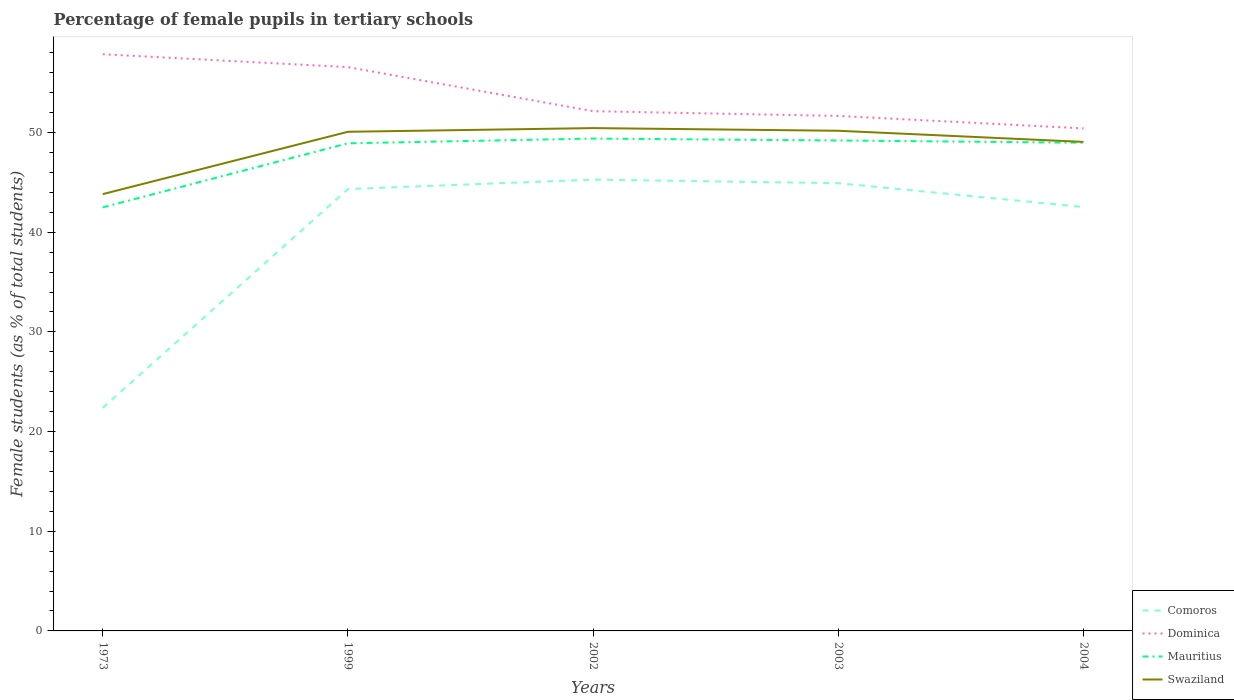How many different coloured lines are there?
Your answer should be very brief. 4. Across all years, what is the maximum percentage of female pupils in tertiary schools in Mauritius?
Your answer should be compact. 42.5. What is the total percentage of female pupils in tertiary schools in Mauritius in the graph?
Your response must be concise. 0.42. What is the difference between the highest and the second highest percentage of female pupils in tertiary schools in Swaziland?
Provide a succinct answer. 6.63. What is the difference between the highest and the lowest percentage of female pupils in tertiary schools in Mauritius?
Make the answer very short. 4. How many lines are there?
Make the answer very short. 4. What is the difference between two consecutive major ticks on the Y-axis?
Offer a terse response. 10. Does the graph contain any zero values?
Give a very brief answer. No. Does the graph contain grids?
Your answer should be very brief. No. Where does the legend appear in the graph?
Offer a very short reply. Bottom right. What is the title of the graph?
Offer a very short reply. Percentage of female pupils in tertiary schools. What is the label or title of the X-axis?
Offer a terse response. Years. What is the label or title of the Y-axis?
Give a very brief answer. Female students (as % of total students). What is the Female students (as % of total students) in Comoros in 1973?
Keep it short and to the point. 22.38. What is the Female students (as % of total students) in Dominica in 1973?
Offer a very short reply. 57.86. What is the Female students (as % of total students) of Mauritius in 1973?
Provide a succinct answer. 42.5. What is the Female students (as % of total students) in Swaziland in 1973?
Give a very brief answer. 43.82. What is the Female students (as % of total students) of Comoros in 1999?
Give a very brief answer. 44.33. What is the Female students (as % of total students) in Dominica in 1999?
Offer a very short reply. 56.57. What is the Female students (as % of total students) of Mauritius in 1999?
Offer a very short reply. 48.92. What is the Female students (as % of total students) in Swaziland in 1999?
Make the answer very short. 50.08. What is the Female students (as % of total students) in Comoros in 2002?
Your response must be concise. 45.28. What is the Female students (as % of total students) of Dominica in 2002?
Offer a very short reply. 52.15. What is the Female students (as % of total students) in Mauritius in 2002?
Provide a short and direct response. 49.4. What is the Female students (as % of total students) in Swaziland in 2002?
Make the answer very short. 50.45. What is the Female students (as % of total students) of Comoros in 2003?
Make the answer very short. 44.92. What is the Female students (as % of total students) of Dominica in 2003?
Keep it short and to the point. 51.67. What is the Female students (as % of total students) of Mauritius in 2003?
Provide a succinct answer. 49.21. What is the Female students (as % of total students) in Swaziland in 2003?
Ensure brevity in your answer.  50.18. What is the Female students (as % of total students) in Comoros in 2004?
Ensure brevity in your answer.  42.53. What is the Female students (as % of total students) of Dominica in 2004?
Your answer should be very brief. 50.42. What is the Female students (as % of total students) of Mauritius in 2004?
Offer a very short reply. 48.98. What is the Female students (as % of total students) of Swaziland in 2004?
Offer a terse response. 49.06. Across all years, what is the maximum Female students (as % of total students) in Comoros?
Make the answer very short. 45.28. Across all years, what is the maximum Female students (as % of total students) of Dominica?
Ensure brevity in your answer.  57.86. Across all years, what is the maximum Female students (as % of total students) in Mauritius?
Ensure brevity in your answer.  49.4. Across all years, what is the maximum Female students (as % of total students) in Swaziland?
Offer a terse response. 50.45. Across all years, what is the minimum Female students (as % of total students) in Comoros?
Offer a terse response. 22.38. Across all years, what is the minimum Female students (as % of total students) of Dominica?
Ensure brevity in your answer.  50.42. Across all years, what is the minimum Female students (as % of total students) in Mauritius?
Provide a succinct answer. 42.5. Across all years, what is the minimum Female students (as % of total students) in Swaziland?
Offer a very short reply. 43.82. What is the total Female students (as % of total students) in Comoros in the graph?
Give a very brief answer. 199.44. What is the total Female students (as % of total students) in Dominica in the graph?
Keep it short and to the point. 268.66. What is the total Female students (as % of total students) of Mauritius in the graph?
Ensure brevity in your answer.  239.01. What is the total Female students (as % of total students) of Swaziland in the graph?
Provide a succinct answer. 243.6. What is the difference between the Female students (as % of total students) in Comoros in 1973 and that in 1999?
Your response must be concise. -21.95. What is the difference between the Female students (as % of total students) of Dominica in 1973 and that in 1999?
Your answer should be compact. 1.29. What is the difference between the Female students (as % of total students) of Mauritius in 1973 and that in 1999?
Your response must be concise. -6.42. What is the difference between the Female students (as % of total students) in Swaziland in 1973 and that in 1999?
Your answer should be very brief. -6.26. What is the difference between the Female students (as % of total students) in Comoros in 1973 and that in 2002?
Your answer should be compact. -22.9. What is the difference between the Female students (as % of total students) of Dominica in 1973 and that in 2002?
Ensure brevity in your answer.  5.71. What is the difference between the Female students (as % of total students) of Mauritius in 1973 and that in 2002?
Offer a very short reply. -6.9. What is the difference between the Female students (as % of total students) in Swaziland in 1973 and that in 2002?
Make the answer very short. -6.63. What is the difference between the Female students (as % of total students) of Comoros in 1973 and that in 2003?
Provide a short and direct response. -22.54. What is the difference between the Female students (as % of total students) of Dominica in 1973 and that in 2003?
Provide a short and direct response. 6.19. What is the difference between the Female students (as % of total students) of Mauritius in 1973 and that in 2003?
Offer a very short reply. -6.71. What is the difference between the Female students (as % of total students) of Swaziland in 1973 and that in 2003?
Give a very brief answer. -6.36. What is the difference between the Female students (as % of total students) in Comoros in 1973 and that in 2004?
Offer a terse response. -20.15. What is the difference between the Female students (as % of total students) in Dominica in 1973 and that in 2004?
Your answer should be very brief. 7.44. What is the difference between the Female students (as % of total students) of Mauritius in 1973 and that in 2004?
Keep it short and to the point. -6.48. What is the difference between the Female students (as % of total students) in Swaziland in 1973 and that in 2004?
Give a very brief answer. -5.24. What is the difference between the Female students (as % of total students) of Comoros in 1999 and that in 2002?
Keep it short and to the point. -0.95. What is the difference between the Female students (as % of total students) in Dominica in 1999 and that in 2002?
Offer a terse response. 4.42. What is the difference between the Female students (as % of total students) of Mauritius in 1999 and that in 2002?
Your response must be concise. -0.48. What is the difference between the Female students (as % of total students) in Swaziland in 1999 and that in 2002?
Make the answer very short. -0.37. What is the difference between the Female students (as % of total students) of Comoros in 1999 and that in 2003?
Provide a short and direct response. -0.59. What is the difference between the Female students (as % of total students) in Dominica in 1999 and that in 2003?
Offer a very short reply. 4.9. What is the difference between the Female students (as % of total students) in Mauritius in 1999 and that in 2003?
Ensure brevity in your answer.  -0.28. What is the difference between the Female students (as % of total students) of Swaziland in 1999 and that in 2003?
Ensure brevity in your answer.  -0.1. What is the difference between the Female students (as % of total students) of Comoros in 1999 and that in 2004?
Ensure brevity in your answer.  1.8. What is the difference between the Female students (as % of total students) in Dominica in 1999 and that in 2004?
Your response must be concise. 6.15. What is the difference between the Female students (as % of total students) in Mauritius in 1999 and that in 2004?
Give a very brief answer. -0.06. What is the difference between the Female students (as % of total students) of Swaziland in 1999 and that in 2004?
Provide a succinct answer. 1.02. What is the difference between the Female students (as % of total students) in Comoros in 2002 and that in 2003?
Give a very brief answer. 0.36. What is the difference between the Female students (as % of total students) in Dominica in 2002 and that in 2003?
Keep it short and to the point. 0.48. What is the difference between the Female students (as % of total students) in Mauritius in 2002 and that in 2003?
Keep it short and to the point. 0.19. What is the difference between the Female students (as % of total students) in Swaziland in 2002 and that in 2003?
Provide a succinct answer. 0.27. What is the difference between the Female students (as % of total students) of Comoros in 2002 and that in 2004?
Give a very brief answer. 2.75. What is the difference between the Female students (as % of total students) in Dominica in 2002 and that in 2004?
Ensure brevity in your answer.  1.73. What is the difference between the Female students (as % of total students) of Mauritius in 2002 and that in 2004?
Ensure brevity in your answer.  0.42. What is the difference between the Female students (as % of total students) of Swaziland in 2002 and that in 2004?
Your answer should be compact. 1.39. What is the difference between the Female students (as % of total students) of Comoros in 2003 and that in 2004?
Your response must be concise. 2.39. What is the difference between the Female students (as % of total students) of Dominica in 2003 and that in 2004?
Your answer should be very brief. 1.25. What is the difference between the Female students (as % of total students) in Mauritius in 2003 and that in 2004?
Provide a succinct answer. 0.23. What is the difference between the Female students (as % of total students) in Swaziland in 2003 and that in 2004?
Keep it short and to the point. 1.12. What is the difference between the Female students (as % of total students) of Comoros in 1973 and the Female students (as % of total students) of Dominica in 1999?
Your answer should be very brief. -34.19. What is the difference between the Female students (as % of total students) in Comoros in 1973 and the Female students (as % of total students) in Mauritius in 1999?
Offer a terse response. -26.54. What is the difference between the Female students (as % of total students) in Comoros in 1973 and the Female students (as % of total students) in Swaziland in 1999?
Make the answer very short. -27.7. What is the difference between the Female students (as % of total students) of Dominica in 1973 and the Female students (as % of total students) of Mauritius in 1999?
Offer a terse response. 8.93. What is the difference between the Female students (as % of total students) of Dominica in 1973 and the Female students (as % of total students) of Swaziland in 1999?
Offer a very short reply. 7.78. What is the difference between the Female students (as % of total students) of Mauritius in 1973 and the Female students (as % of total students) of Swaziland in 1999?
Provide a short and direct response. -7.58. What is the difference between the Female students (as % of total students) in Comoros in 1973 and the Female students (as % of total students) in Dominica in 2002?
Provide a succinct answer. -29.77. What is the difference between the Female students (as % of total students) in Comoros in 1973 and the Female students (as % of total students) in Mauritius in 2002?
Make the answer very short. -27.02. What is the difference between the Female students (as % of total students) of Comoros in 1973 and the Female students (as % of total students) of Swaziland in 2002?
Make the answer very short. -28.07. What is the difference between the Female students (as % of total students) of Dominica in 1973 and the Female students (as % of total students) of Mauritius in 2002?
Provide a succinct answer. 8.46. What is the difference between the Female students (as % of total students) in Dominica in 1973 and the Female students (as % of total students) in Swaziland in 2002?
Your answer should be compact. 7.41. What is the difference between the Female students (as % of total students) of Mauritius in 1973 and the Female students (as % of total students) of Swaziland in 2002?
Make the answer very short. -7.95. What is the difference between the Female students (as % of total students) in Comoros in 1973 and the Female students (as % of total students) in Dominica in 2003?
Your answer should be very brief. -29.29. What is the difference between the Female students (as % of total students) of Comoros in 1973 and the Female students (as % of total students) of Mauritius in 2003?
Offer a very short reply. -26.83. What is the difference between the Female students (as % of total students) in Comoros in 1973 and the Female students (as % of total students) in Swaziland in 2003?
Make the answer very short. -27.8. What is the difference between the Female students (as % of total students) of Dominica in 1973 and the Female students (as % of total students) of Mauritius in 2003?
Keep it short and to the point. 8.65. What is the difference between the Female students (as % of total students) in Dominica in 1973 and the Female students (as % of total students) in Swaziland in 2003?
Your response must be concise. 7.68. What is the difference between the Female students (as % of total students) of Mauritius in 1973 and the Female students (as % of total students) of Swaziland in 2003?
Ensure brevity in your answer.  -7.68. What is the difference between the Female students (as % of total students) of Comoros in 1973 and the Female students (as % of total students) of Dominica in 2004?
Your answer should be very brief. -28.04. What is the difference between the Female students (as % of total students) of Comoros in 1973 and the Female students (as % of total students) of Mauritius in 2004?
Give a very brief answer. -26.6. What is the difference between the Female students (as % of total students) of Comoros in 1973 and the Female students (as % of total students) of Swaziland in 2004?
Give a very brief answer. -26.69. What is the difference between the Female students (as % of total students) in Dominica in 1973 and the Female students (as % of total students) in Mauritius in 2004?
Offer a terse response. 8.88. What is the difference between the Female students (as % of total students) of Dominica in 1973 and the Female students (as % of total students) of Swaziland in 2004?
Provide a short and direct response. 8.79. What is the difference between the Female students (as % of total students) in Mauritius in 1973 and the Female students (as % of total students) in Swaziland in 2004?
Offer a terse response. -6.57. What is the difference between the Female students (as % of total students) in Comoros in 1999 and the Female students (as % of total students) in Dominica in 2002?
Keep it short and to the point. -7.82. What is the difference between the Female students (as % of total students) of Comoros in 1999 and the Female students (as % of total students) of Mauritius in 2002?
Offer a terse response. -5.07. What is the difference between the Female students (as % of total students) in Comoros in 1999 and the Female students (as % of total students) in Swaziland in 2002?
Your answer should be compact. -6.12. What is the difference between the Female students (as % of total students) in Dominica in 1999 and the Female students (as % of total students) in Mauritius in 2002?
Ensure brevity in your answer.  7.17. What is the difference between the Female students (as % of total students) in Dominica in 1999 and the Female students (as % of total students) in Swaziland in 2002?
Your answer should be compact. 6.12. What is the difference between the Female students (as % of total students) of Mauritius in 1999 and the Female students (as % of total students) of Swaziland in 2002?
Provide a succinct answer. -1.53. What is the difference between the Female students (as % of total students) in Comoros in 1999 and the Female students (as % of total students) in Dominica in 2003?
Offer a very short reply. -7.34. What is the difference between the Female students (as % of total students) of Comoros in 1999 and the Female students (as % of total students) of Mauritius in 2003?
Offer a terse response. -4.88. What is the difference between the Female students (as % of total students) in Comoros in 1999 and the Female students (as % of total students) in Swaziland in 2003?
Offer a terse response. -5.85. What is the difference between the Female students (as % of total students) in Dominica in 1999 and the Female students (as % of total students) in Mauritius in 2003?
Offer a very short reply. 7.36. What is the difference between the Female students (as % of total students) in Dominica in 1999 and the Female students (as % of total students) in Swaziland in 2003?
Offer a terse response. 6.39. What is the difference between the Female students (as % of total students) of Mauritius in 1999 and the Female students (as % of total students) of Swaziland in 2003?
Your answer should be compact. -1.26. What is the difference between the Female students (as % of total students) in Comoros in 1999 and the Female students (as % of total students) in Dominica in 2004?
Your answer should be very brief. -6.09. What is the difference between the Female students (as % of total students) of Comoros in 1999 and the Female students (as % of total students) of Mauritius in 2004?
Ensure brevity in your answer.  -4.65. What is the difference between the Female students (as % of total students) in Comoros in 1999 and the Female students (as % of total students) in Swaziland in 2004?
Offer a terse response. -4.73. What is the difference between the Female students (as % of total students) of Dominica in 1999 and the Female students (as % of total students) of Mauritius in 2004?
Ensure brevity in your answer.  7.59. What is the difference between the Female students (as % of total students) of Dominica in 1999 and the Female students (as % of total students) of Swaziland in 2004?
Your response must be concise. 7.5. What is the difference between the Female students (as % of total students) of Mauritius in 1999 and the Female students (as % of total students) of Swaziland in 2004?
Your answer should be very brief. -0.14. What is the difference between the Female students (as % of total students) of Comoros in 2002 and the Female students (as % of total students) of Dominica in 2003?
Provide a short and direct response. -6.39. What is the difference between the Female students (as % of total students) of Comoros in 2002 and the Female students (as % of total students) of Mauritius in 2003?
Provide a short and direct response. -3.93. What is the difference between the Female students (as % of total students) of Comoros in 2002 and the Female students (as % of total students) of Swaziland in 2003?
Keep it short and to the point. -4.9. What is the difference between the Female students (as % of total students) of Dominica in 2002 and the Female students (as % of total students) of Mauritius in 2003?
Your answer should be very brief. 2.94. What is the difference between the Female students (as % of total students) of Dominica in 2002 and the Female students (as % of total students) of Swaziland in 2003?
Provide a short and direct response. 1.97. What is the difference between the Female students (as % of total students) of Mauritius in 2002 and the Female students (as % of total students) of Swaziland in 2003?
Give a very brief answer. -0.78. What is the difference between the Female students (as % of total students) in Comoros in 2002 and the Female students (as % of total students) in Dominica in 2004?
Your response must be concise. -5.14. What is the difference between the Female students (as % of total students) in Comoros in 2002 and the Female students (as % of total students) in Mauritius in 2004?
Your response must be concise. -3.7. What is the difference between the Female students (as % of total students) of Comoros in 2002 and the Female students (as % of total students) of Swaziland in 2004?
Your answer should be compact. -3.79. What is the difference between the Female students (as % of total students) of Dominica in 2002 and the Female students (as % of total students) of Mauritius in 2004?
Your answer should be compact. 3.17. What is the difference between the Female students (as % of total students) of Dominica in 2002 and the Female students (as % of total students) of Swaziland in 2004?
Provide a succinct answer. 3.08. What is the difference between the Female students (as % of total students) of Mauritius in 2002 and the Female students (as % of total students) of Swaziland in 2004?
Give a very brief answer. 0.34. What is the difference between the Female students (as % of total students) of Comoros in 2003 and the Female students (as % of total students) of Dominica in 2004?
Make the answer very short. -5.5. What is the difference between the Female students (as % of total students) of Comoros in 2003 and the Female students (as % of total students) of Mauritius in 2004?
Provide a succinct answer. -4.06. What is the difference between the Female students (as % of total students) of Comoros in 2003 and the Female students (as % of total students) of Swaziland in 2004?
Offer a terse response. -4.14. What is the difference between the Female students (as % of total students) in Dominica in 2003 and the Female students (as % of total students) in Mauritius in 2004?
Ensure brevity in your answer.  2.69. What is the difference between the Female students (as % of total students) of Dominica in 2003 and the Female students (as % of total students) of Swaziland in 2004?
Your response must be concise. 2.61. What is the difference between the Female students (as % of total students) of Mauritius in 2003 and the Female students (as % of total students) of Swaziland in 2004?
Your response must be concise. 0.14. What is the average Female students (as % of total students) of Comoros per year?
Your answer should be compact. 39.89. What is the average Female students (as % of total students) in Dominica per year?
Your answer should be very brief. 53.73. What is the average Female students (as % of total students) in Mauritius per year?
Keep it short and to the point. 47.8. What is the average Female students (as % of total students) of Swaziland per year?
Provide a succinct answer. 48.72. In the year 1973, what is the difference between the Female students (as % of total students) in Comoros and Female students (as % of total students) in Dominica?
Provide a succinct answer. -35.48. In the year 1973, what is the difference between the Female students (as % of total students) of Comoros and Female students (as % of total students) of Mauritius?
Offer a very short reply. -20.12. In the year 1973, what is the difference between the Female students (as % of total students) of Comoros and Female students (as % of total students) of Swaziland?
Provide a short and direct response. -21.45. In the year 1973, what is the difference between the Female students (as % of total students) in Dominica and Female students (as % of total students) in Mauritius?
Your response must be concise. 15.36. In the year 1973, what is the difference between the Female students (as % of total students) of Dominica and Female students (as % of total students) of Swaziland?
Ensure brevity in your answer.  14.03. In the year 1973, what is the difference between the Female students (as % of total students) in Mauritius and Female students (as % of total students) in Swaziland?
Your answer should be compact. -1.33. In the year 1999, what is the difference between the Female students (as % of total students) in Comoros and Female students (as % of total students) in Dominica?
Provide a succinct answer. -12.24. In the year 1999, what is the difference between the Female students (as % of total students) of Comoros and Female students (as % of total students) of Mauritius?
Your response must be concise. -4.59. In the year 1999, what is the difference between the Female students (as % of total students) in Comoros and Female students (as % of total students) in Swaziland?
Ensure brevity in your answer.  -5.75. In the year 1999, what is the difference between the Female students (as % of total students) of Dominica and Female students (as % of total students) of Mauritius?
Your response must be concise. 7.64. In the year 1999, what is the difference between the Female students (as % of total students) in Dominica and Female students (as % of total students) in Swaziland?
Provide a short and direct response. 6.49. In the year 1999, what is the difference between the Female students (as % of total students) of Mauritius and Female students (as % of total students) of Swaziland?
Offer a very short reply. -1.16. In the year 2002, what is the difference between the Female students (as % of total students) in Comoros and Female students (as % of total students) in Dominica?
Your response must be concise. -6.87. In the year 2002, what is the difference between the Female students (as % of total students) in Comoros and Female students (as % of total students) in Mauritius?
Your answer should be compact. -4.12. In the year 2002, what is the difference between the Female students (as % of total students) of Comoros and Female students (as % of total students) of Swaziland?
Give a very brief answer. -5.17. In the year 2002, what is the difference between the Female students (as % of total students) in Dominica and Female students (as % of total students) in Mauritius?
Offer a very short reply. 2.75. In the year 2002, what is the difference between the Female students (as % of total students) in Dominica and Female students (as % of total students) in Swaziland?
Provide a succinct answer. 1.7. In the year 2002, what is the difference between the Female students (as % of total students) of Mauritius and Female students (as % of total students) of Swaziland?
Offer a very short reply. -1.05. In the year 2003, what is the difference between the Female students (as % of total students) in Comoros and Female students (as % of total students) in Dominica?
Offer a very short reply. -6.75. In the year 2003, what is the difference between the Female students (as % of total students) of Comoros and Female students (as % of total students) of Mauritius?
Ensure brevity in your answer.  -4.28. In the year 2003, what is the difference between the Female students (as % of total students) of Comoros and Female students (as % of total students) of Swaziland?
Your answer should be compact. -5.26. In the year 2003, what is the difference between the Female students (as % of total students) of Dominica and Female students (as % of total students) of Mauritius?
Your answer should be compact. 2.46. In the year 2003, what is the difference between the Female students (as % of total students) in Dominica and Female students (as % of total students) in Swaziland?
Give a very brief answer. 1.49. In the year 2003, what is the difference between the Female students (as % of total students) of Mauritius and Female students (as % of total students) of Swaziland?
Keep it short and to the point. -0.97. In the year 2004, what is the difference between the Female students (as % of total students) of Comoros and Female students (as % of total students) of Dominica?
Make the answer very short. -7.89. In the year 2004, what is the difference between the Female students (as % of total students) in Comoros and Female students (as % of total students) in Mauritius?
Offer a terse response. -6.45. In the year 2004, what is the difference between the Female students (as % of total students) of Comoros and Female students (as % of total students) of Swaziland?
Make the answer very short. -6.53. In the year 2004, what is the difference between the Female students (as % of total students) of Dominica and Female students (as % of total students) of Mauritius?
Give a very brief answer. 1.44. In the year 2004, what is the difference between the Female students (as % of total students) of Dominica and Female students (as % of total students) of Swaziland?
Give a very brief answer. 1.36. In the year 2004, what is the difference between the Female students (as % of total students) of Mauritius and Female students (as % of total students) of Swaziland?
Make the answer very short. -0.08. What is the ratio of the Female students (as % of total students) of Comoros in 1973 to that in 1999?
Provide a succinct answer. 0.5. What is the ratio of the Female students (as % of total students) in Dominica in 1973 to that in 1999?
Provide a short and direct response. 1.02. What is the ratio of the Female students (as % of total students) in Mauritius in 1973 to that in 1999?
Offer a very short reply. 0.87. What is the ratio of the Female students (as % of total students) in Swaziland in 1973 to that in 1999?
Offer a very short reply. 0.88. What is the ratio of the Female students (as % of total students) of Comoros in 1973 to that in 2002?
Make the answer very short. 0.49. What is the ratio of the Female students (as % of total students) in Dominica in 1973 to that in 2002?
Provide a short and direct response. 1.11. What is the ratio of the Female students (as % of total students) of Mauritius in 1973 to that in 2002?
Make the answer very short. 0.86. What is the ratio of the Female students (as % of total students) in Swaziland in 1973 to that in 2002?
Provide a short and direct response. 0.87. What is the ratio of the Female students (as % of total students) of Comoros in 1973 to that in 2003?
Offer a very short reply. 0.5. What is the ratio of the Female students (as % of total students) of Dominica in 1973 to that in 2003?
Your answer should be compact. 1.12. What is the ratio of the Female students (as % of total students) of Mauritius in 1973 to that in 2003?
Your answer should be very brief. 0.86. What is the ratio of the Female students (as % of total students) of Swaziland in 1973 to that in 2003?
Offer a terse response. 0.87. What is the ratio of the Female students (as % of total students) in Comoros in 1973 to that in 2004?
Provide a short and direct response. 0.53. What is the ratio of the Female students (as % of total students) of Dominica in 1973 to that in 2004?
Your response must be concise. 1.15. What is the ratio of the Female students (as % of total students) in Mauritius in 1973 to that in 2004?
Ensure brevity in your answer.  0.87. What is the ratio of the Female students (as % of total students) in Swaziland in 1973 to that in 2004?
Provide a short and direct response. 0.89. What is the ratio of the Female students (as % of total students) of Comoros in 1999 to that in 2002?
Make the answer very short. 0.98. What is the ratio of the Female students (as % of total students) in Dominica in 1999 to that in 2002?
Your answer should be compact. 1.08. What is the ratio of the Female students (as % of total students) of Mauritius in 1999 to that in 2002?
Keep it short and to the point. 0.99. What is the ratio of the Female students (as % of total students) in Dominica in 1999 to that in 2003?
Offer a terse response. 1.09. What is the ratio of the Female students (as % of total students) of Mauritius in 1999 to that in 2003?
Provide a succinct answer. 0.99. What is the ratio of the Female students (as % of total students) in Swaziland in 1999 to that in 2003?
Offer a terse response. 1. What is the ratio of the Female students (as % of total students) of Comoros in 1999 to that in 2004?
Keep it short and to the point. 1.04. What is the ratio of the Female students (as % of total students) in Dominica in 1999 to that in 2004?
Make the answer very short. 1.12. What is the ratio of the Female students (as % of total students) in Swaziland in 1999 to that in 2004?
Make the answer very short. 1.02. What is the ratio of the Female students (as % of total students) in Comoros in 2002 to that in 2003?
Make the answer very short. 1.01. What is the ratio of the Female students (as % of total students) of Dominica in 2002 to that in 2003?
Provide a succinct answer. 1.01. What is the ratio of the Female students (as % of total students) of Mauritius in 2002 to that in 2003?
Keep it short and to the point. 1. What is the ratio of the Female students (as % of total students) in Swaziland in 2002 to that in 2003?
Offer a very short reply. 1.01. What is the ratio of the Female students (as % of total students) of Comoros in 2002 to that in 2004?
Your answer should be compact. 1.06. What is the ratio of the Female students (as % of total students) in Dominica in 2002 to that in 2004?
Your answer should be very brief. 1.03. What is the ratio of the Female students (as % of total students) of Mauritius in 2002 to that in 2004?
Your answer should be very brief. 1.01. What is the ratio of the Female students (as % of total students) in Swaziland in 2002 to that in 2004?
Your answer should be compact. 1.03. What is the ratio of the Female students (as % of total students) in Comoros in 2003 to that in 2004?
Your response must be concise. 1.06. What is the ratio of the Female students (as % of total students) of Dominica in 2003 to that in 2004?
Provide a succinct answer. 1.02. What is the ratio of the Female students (as % of total students) of Swaziland in 2003 to that in 2004?
Your response must be concise. 1.02. What is the difference between the highest and the second highest Female students (as % of total students) in Comoros?
Offer a terse response. 0.36. What is the difference between the highest and the second highest Female students (as % of total students) in Dominica?
Your response must be concise. 1.29. What is the difference between the highest and the second highest Female students (as % of total students) of Mauritius?
Your response must be concise. 0.19. What is the difference between the highest and the second highest Female students (as % of total students) in Swaziland?
Provide a succinct answer. 0.27. What is the difference between the highest and the lowest Female students (as % of total students) in Comoros?
Make the answer very short. 22.9. What is the difference between the highest and the lowest Female students (as % of total students) of Dominica?
Your answer should be compact. 7.44. What is the difference between the highest and the lowest Female students (as % of total students) in Mauritius?
Keep it short and to the point. 6.9. What is the difference between the highest and the lowest Female students (as % of total students) of Swaziland?
Provide a succinct answer. 6.63. 